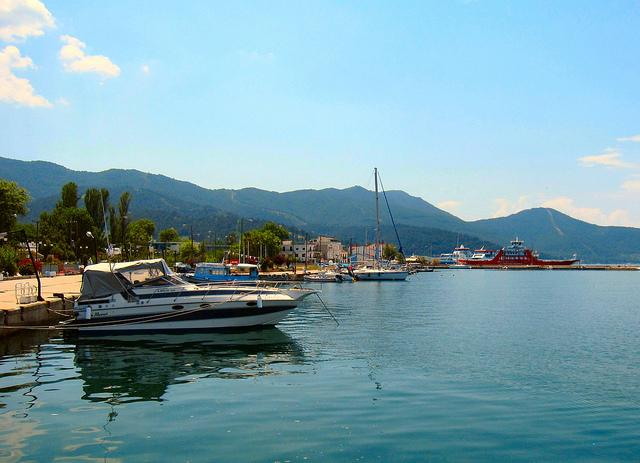What can usually be found in this setting? fish 